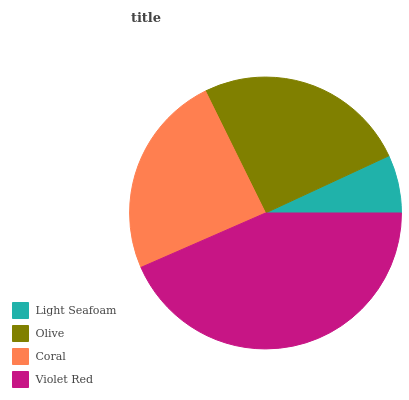Is Light Seafoam the minimum?
Answer yes or no. Yes. Is Violet Red the maximum?
Answer yes or no. Yes. Is Olive the minimum?
Answer yes or no. No. Is Olive the maximum?
Answer yes or no. No. Is Olive greater than Light Seafoam?
Answer yes or no. Yes. Is Light Seafoam less than Olive?
Answer yes or no. Yes. Is Light Seafoam greater than Olive?
Answer yes or no. No. Is Olive less than Light Seafoam?
Answer yes or no. No. Is Olive the high median?
Answer yes or no. Yes. Is Coral the low median?
Answer yes or no. Yes. Is Light Seafoam the high median?
Answer yes or no. No. Is Violet Red the low median?
Answer yes or no. No. 